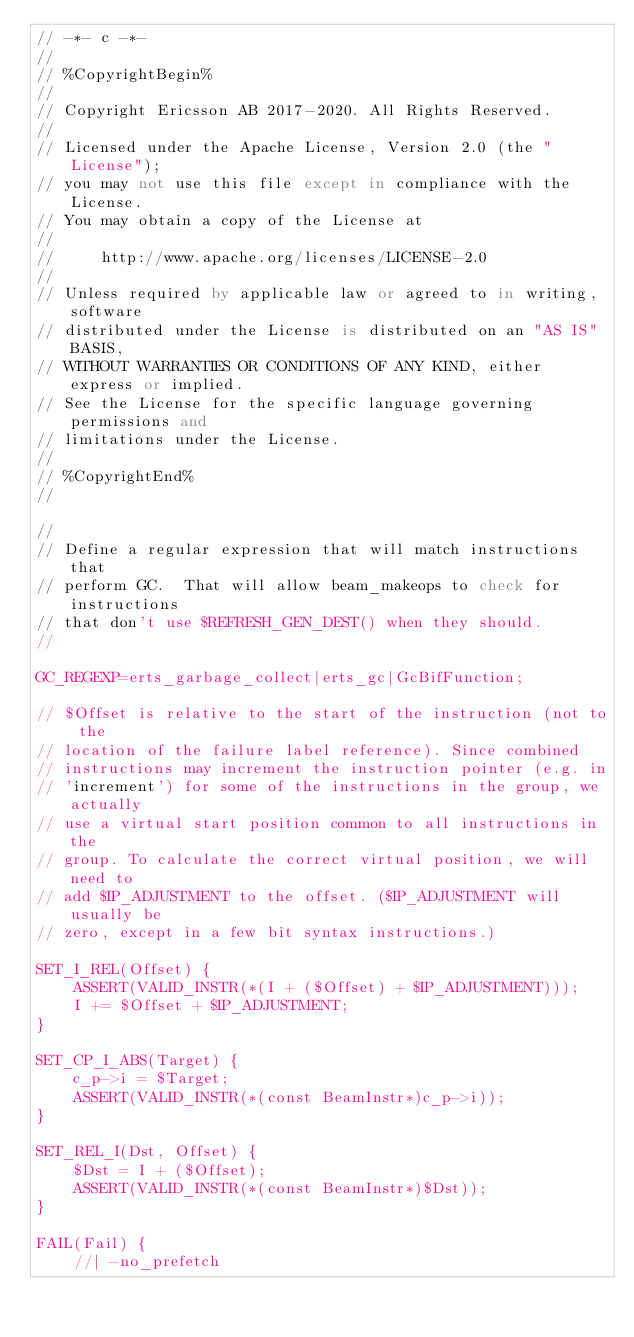Convert code to text. <code><loc_0><loc_0><loc_500><loc_500><_SQL_>// -*- c -*-
//
// %CopyrightBegin%
//
// Copyright Ericsson AB 2017-2020. All Rights Reserved.
//
// Licensed under the Apache License, Version 2.0 (the "License");
// you may not use this file except in compliance with the License.
// You may obtain a copy of the License at
//
//     http://www.apache.org/licenses/LICENSE-2.0
//
// Unless required by applicable law or agreed to in writing, software
// distributed under the License is distributed on an "AS IS" BASIS,
// WITHOUT WARRANTIES OR CONDITIONS OF ANY KIND, either express or implied.
// See the License for the specific language governing permissions and
// limitations under the License.
//
// %CopyrightEnd%
//

//
// Define a regular expression that will match instructions that
// perform GC.  That will allow beam_makeops to check for instructions
// that don't use $REFRESH_GEN_DEST() when they should.
//

GC_REGEXP=erts_garbage_collect|erts_gc|GcBifFunction;

// $Offset is relative to the start of the instruction (not to the
// location of the failure label reference). Since combined
// instructions may increment the instruction pointer (e.g. in
// 'increment') for some of the instructions in the group, we actually
// use a virtual start position common to all instructions in the
// group. To calculate the correct virtual position, we will need to
// add $IP_ADJUSTMENT to the offset. ($IP_ADJUSTMENT will usually be
// zero, except in a few bit syntax instructions.)

SET_I_REL(Offset) {
    ASSERT(VALID_INSTR(*(I + ($Offset) + $IP_ADJUSTMENT)));
    I += $Offset + $IP_ADJUSTMENT;
}

SET_CP_I_ABS(Target) {
    c_p->i = $Target;
    ASSERT(VALID_INSTR(*(const BeamInstr*)c_p->i));
}

SET_REL_I(Dst, Offset) {
    $Dst = I + ($Offset);
    ASSERT(VALID_INSTR(*(const BeamInstr*)$Dst));
}

FAIL(Fail) {
    //| -no_prefetch</code> 